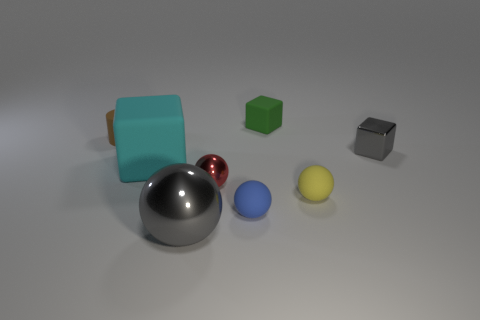What time of day or lighting conditions does the scene represent? The lighting conditions in the scene mimic a soft, diffused, overhead light, possibly simulating an indoor setting. The shadows are soft-edged and fall mostly below the objects, indicating the light source is coming from above. 